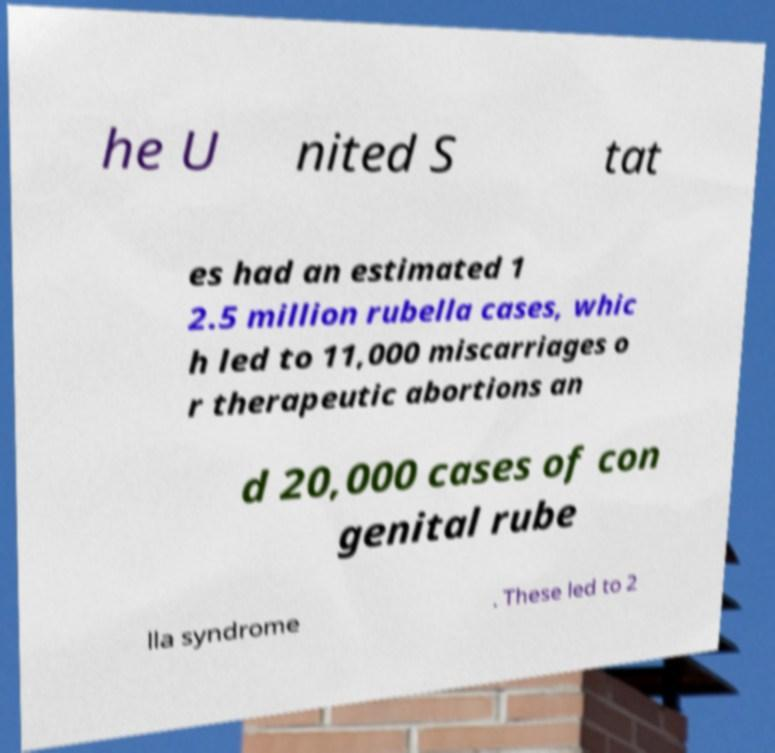Could you extract and type out the text from this image? he U nited S tat es had an estimated 1 2.5 million rubella cases, whic h led to 11,000 miscarriages o r therapeutic abortions an d 20,000 cases of con genital rube lla syndrome . These led to 2 